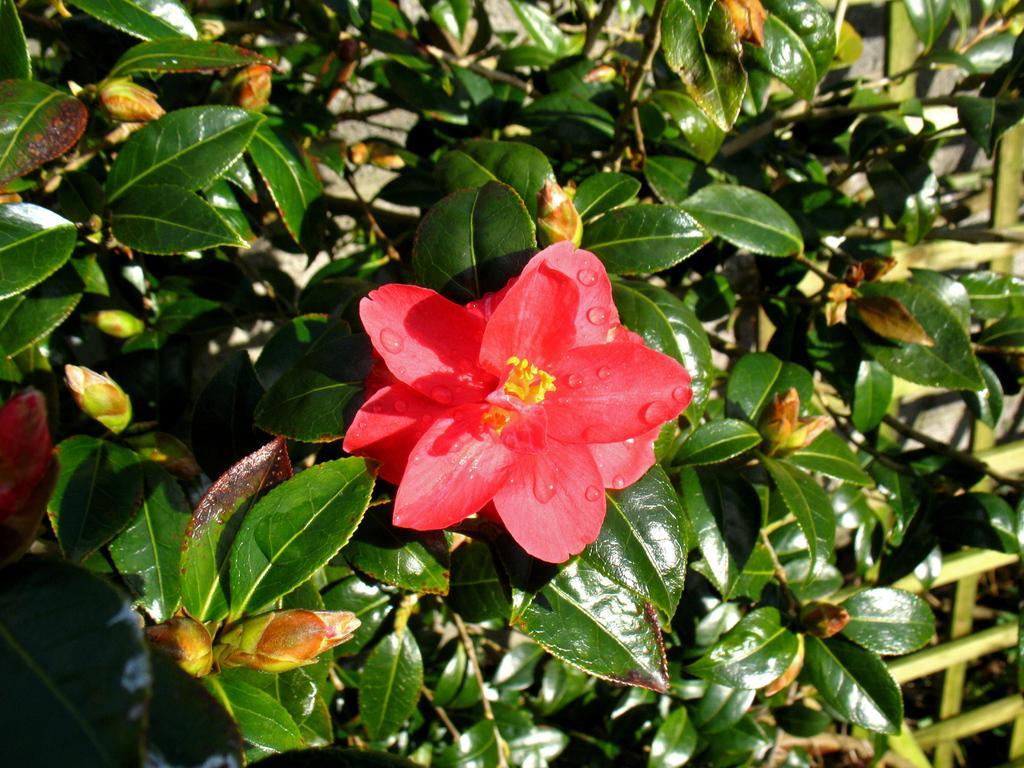Can you describe this image briefly? In this picture we can see a flower and few leaves. 